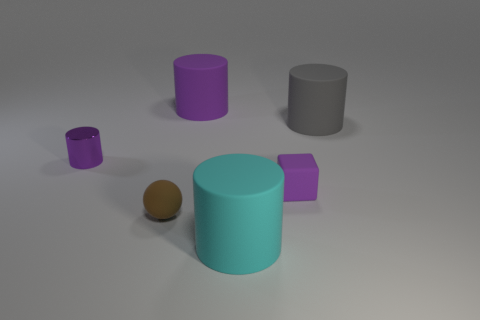Subtract all green cylinders. Subtract all green balls. How many cylinders are left? 4 Add 4 big matte things. How many objects exist? 10 Subtract all cubes. How many objects are left? 5 Add 4 brown matte cylinders. How many brown matte cylinders exist? 4 Subtract 0 cyan spheres. How many objects are left? 6 Subtract all cyan rubber objects. Subtract all matte balls. How many objects are left? 4 Add 4 brown matte objects. How many brown matte objects are left? 5 